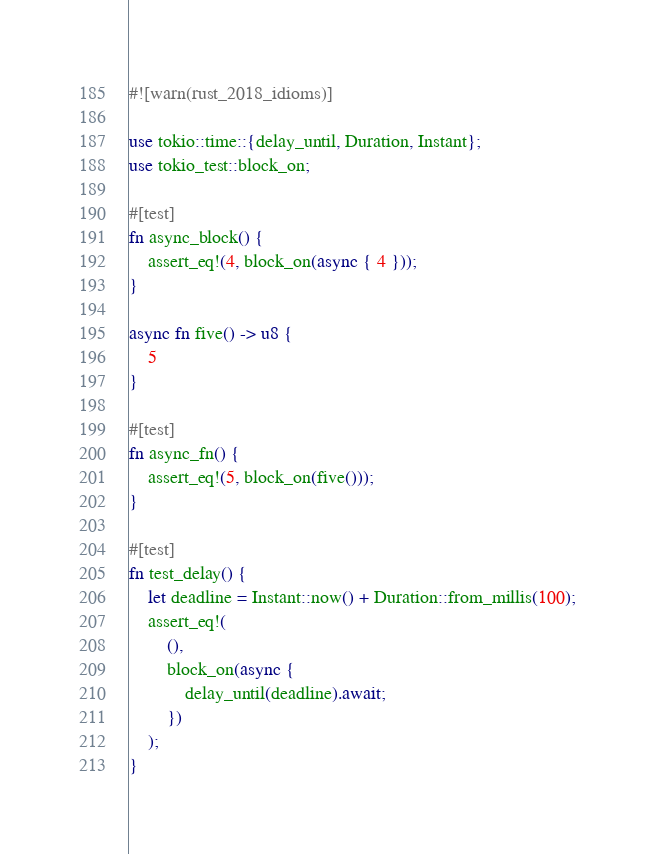Convert code to text. <code><loc_0><loc_0><loc_500><loc_500><_Rust_>#![warn(rust_2018_idioms)]

use tokio::time::{delay_until, Duration, Instant};
use tokio_test::block_on;

#[test]
fn async_block() {
    assert_eq!(4, block_on(async { 4 }));
}

async fn five() -> u8 {
    5
}

#[test]
fn async_fn() {
    assert_eq!(5, block_on(five()));
}

#[test]
fn test_delay() {
    let deadline = Instant::now() + Duration::from_millis(100);
    assert_eq!(
        (),
        block_on(async {
            delay_until(deadline).await;
        })
    );
}
</code> 